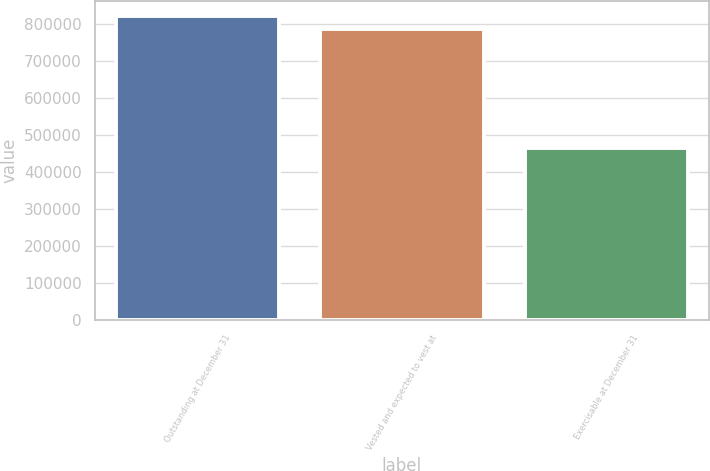<chart> <loc_0><loc_0><loc_500><loc_500><bar_chart><fcel>Outstanding at December 31<fcel>Vested and expected to vest at<fcel>Exercisable at December 31<nl><fcel>821518<fcel>787182<fcel>464685<nl></chart> 